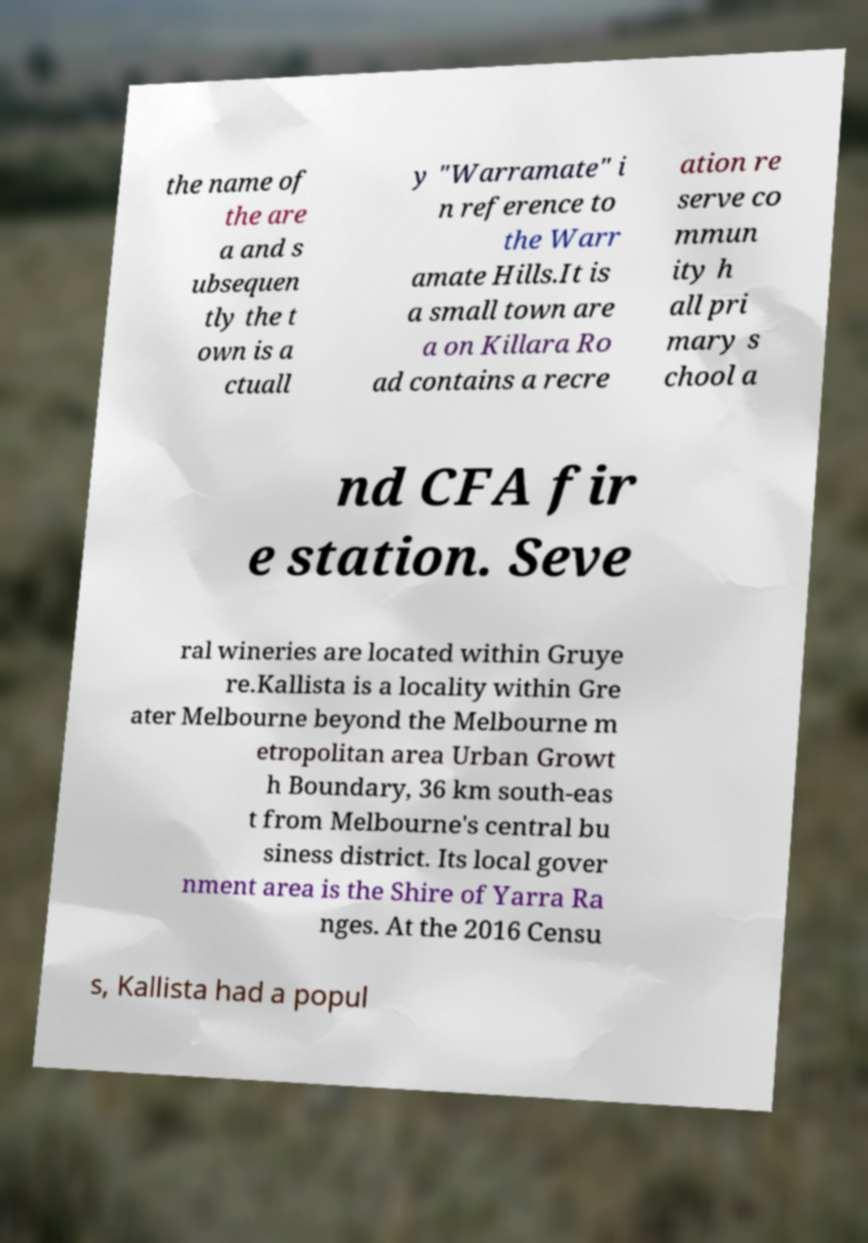Please read and relay the text visible in this image. What does it say? the name of the are a and s ubsequen tly the t own is a ctuall y "Warramate" i n reference to the Warr amate Hills.It is a small town are a on Killara Ro ad contains a recre ation re serve co mmun ity h all pri mary s chool a nd CFA fir e station. Seve ral wineries are located within Gruye re.Kallista is a locality within Gre ater Melbourne beyond the Melbourne m etropolitan area Urban Growt h Boundary, 36 km south-eas t from Melbourne's central bu siness district. Its local gover nment area is the Shire of Yarra Ra nges. At the 2016 Censu s, Kallista had a popul 